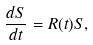Convert formula to latex. <formula><loc_0><loc_0><loc_500><loc_500>\frac { d S } { d t } = R ( t ) S ,</formula> 